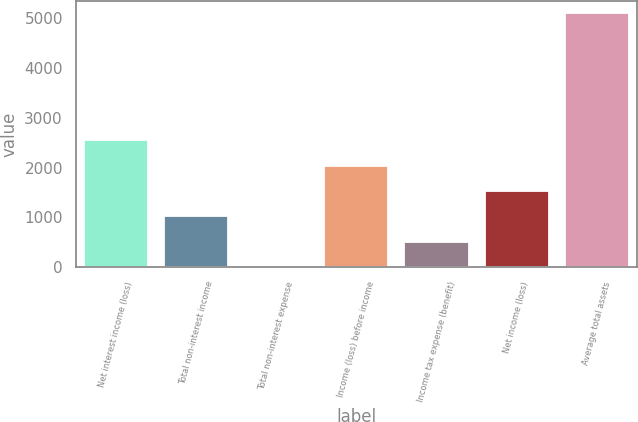<chart> <loc_0><loc_0><loc_500><loc_500><bar_chart><fcel>Net interest income (loss)<fcel>Total non-interest income<fcel>Total non-interest expense<fcel>Income (loss) before income<fcel>Income tax expense (benefit)<fcel>Net income (loss)<fcel>Average total assets<nl><fcel>2550.35<fcel>1020.86<fcel>1.2<fcel>2040.52<fcel>511.03<fcel>1530.69<fcel>5099.5<nl></chart> 